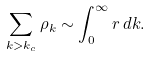<formula> <loc_0><loc_0><loc_500><loc_500>\sum _ { k > k _ { c } } \rho _ { k } \sim \int _ { 0 } ^ { \infty } r \, d k .</formula> 